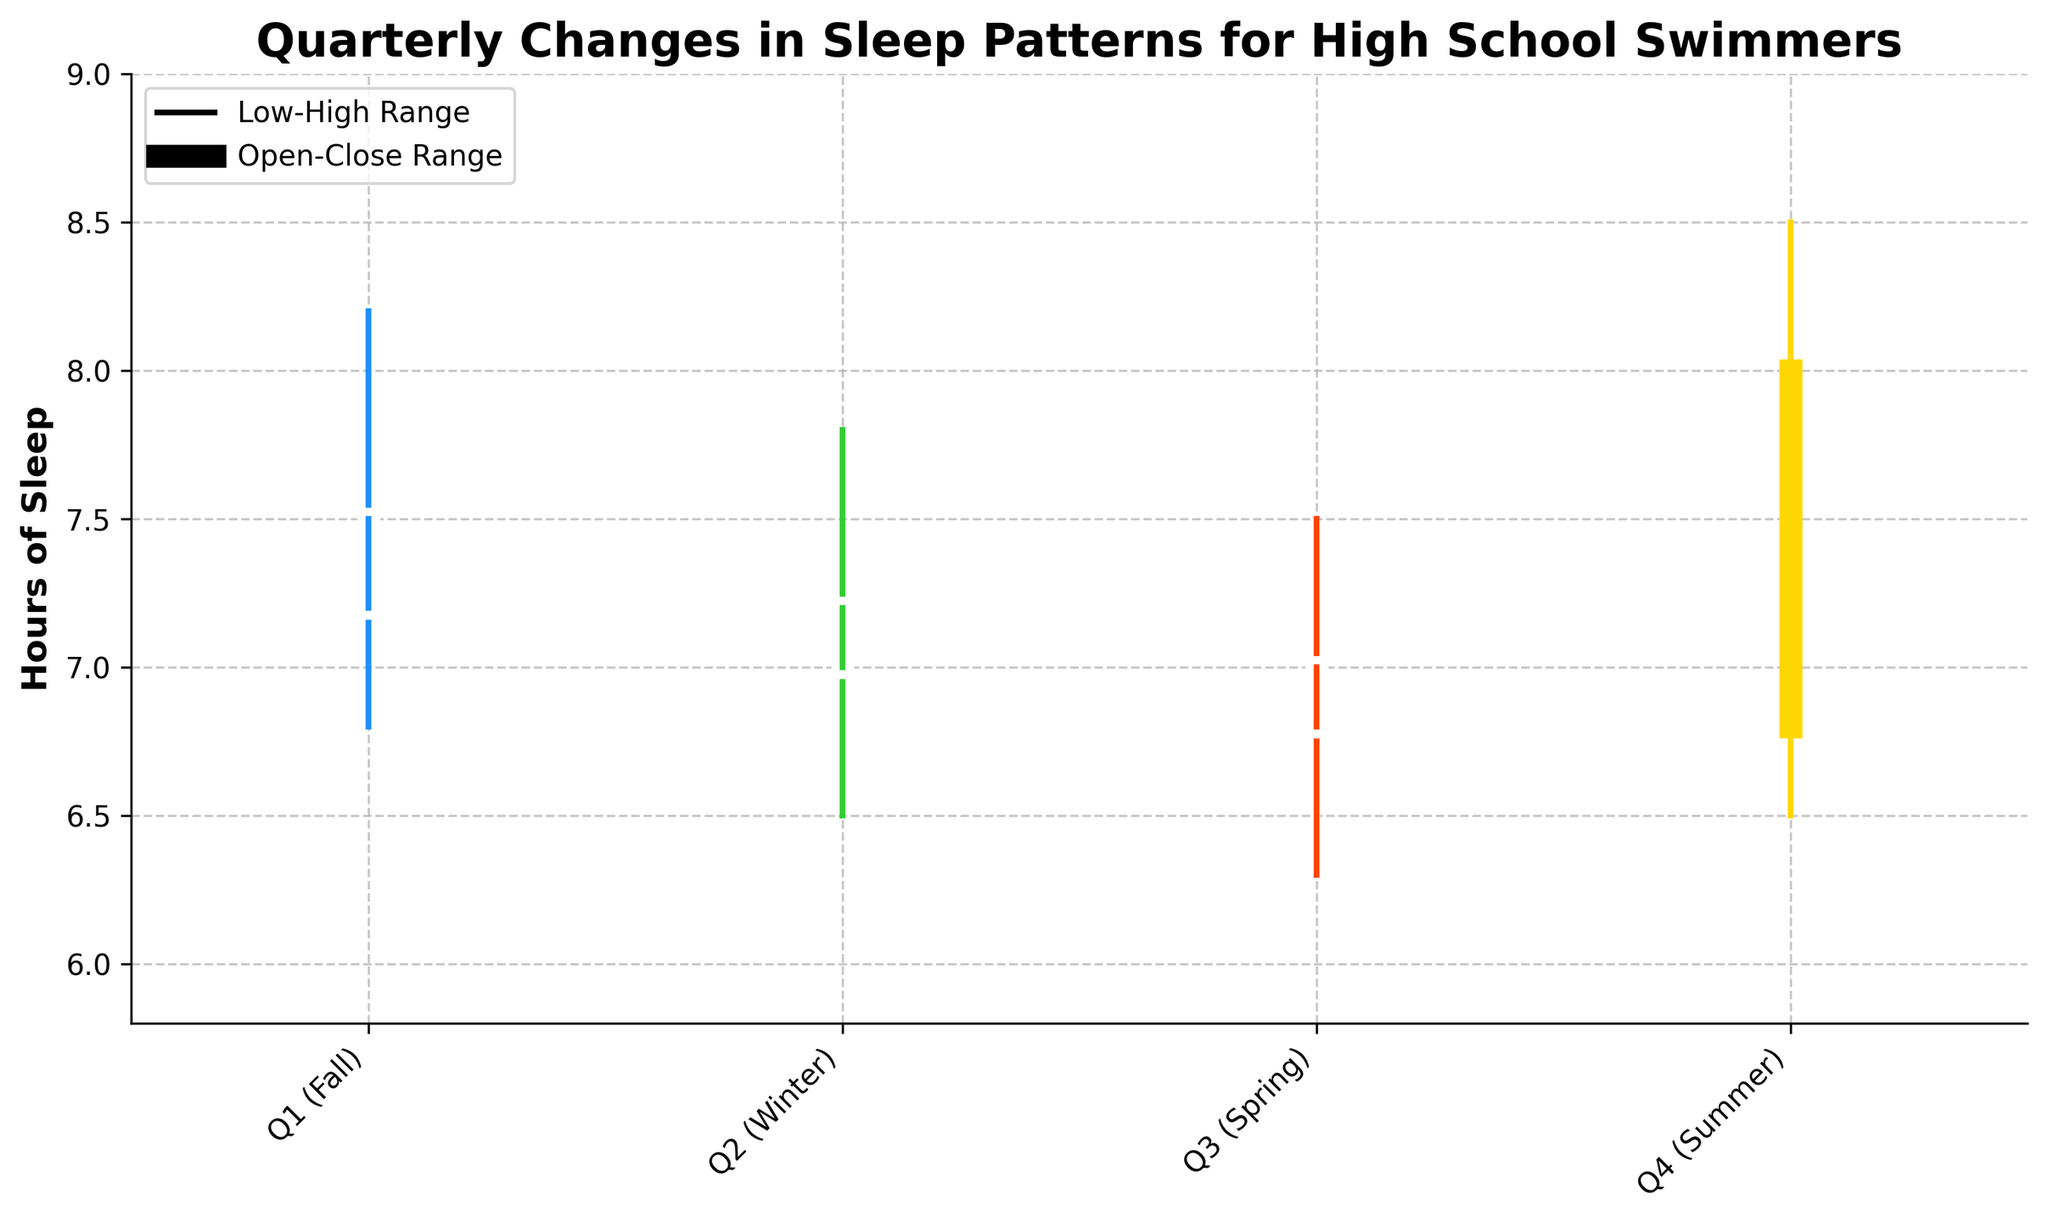What is the title of the figure? The title is displayed at the top of the figure and summarizes the content of the chart.
Answer: Quarterly Changes in Sleep Patterns for High School Swimmers How many quarters are displayed in the chart? The x-axis of the chart lists the quarters being evaluated.
Answer: 4 Which quarter had the highest peak in sleep hours? To determine the highest peak in sleep hours, locate the highest point on the chart.
Answer: Q4 (Summer) What was the range of sleep hours in Q1 (Fall)? Identify the highest and lowest sleep hours for Q1 and subtract the lowest from the highest. The highest is 8.2 hours and the lowest is 6.8 hours.
Answer: 1.4 hours Which quarter showed the least amount of sleep hours at its lowest point? Compare the lowest points for each quarter. The lowest value is 6.3 hours in Q3 (Spring).
Answer: Q3 (Spring) What is the difference between the highest and lowest sleep hours in Winter? Subtract the low from the high for Winter (Q2): 7.8 - 6.5 = 1.3 hours.
Answer: 1.3 hours Did sleep hours increase or decrease between Fall and Winter? Observe the close values from Fall and Winter. Fall closes at 7.2, Winter closes at 7.0.
Answer: Decrease Which quarter had the smallest range between its opening and closing hours? Calculate the range: Fall (7.5 - 7.2 = 0.3), Winter (7.2 - 7.0 = 0.2), Spring (7.0 - 6.8 = 0.2), Summer (6.8 - 8.0 = -1.2). The smallest non-negative range is 0.2.
Answer: Winter (Q2) and Spring (Q3) Which quarter exhibited the widest daily fluctuation in sleep hours? Measure the distance from low to high for each quarter. The widest fluctuation is in Summer, between 6.5 and 8.5.
Answer: Q4 (Summer) In which quarter did the close value exceed the open value? Compare open and close values for each quarter. Summer (Q4) is the only quarter where the close (8.0) is higher than the open (6.8).
Answer: Q4 (Summer) 